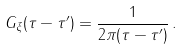<formula> <loc_0><loc_0><loc_500><loc_500>G _ { \xi } ( \tau - \tau ^ { \prime } ) = \frac { 1 } { 2 \pi ( \tau - \tau ^ { \prime } ) } \, .</formula> 